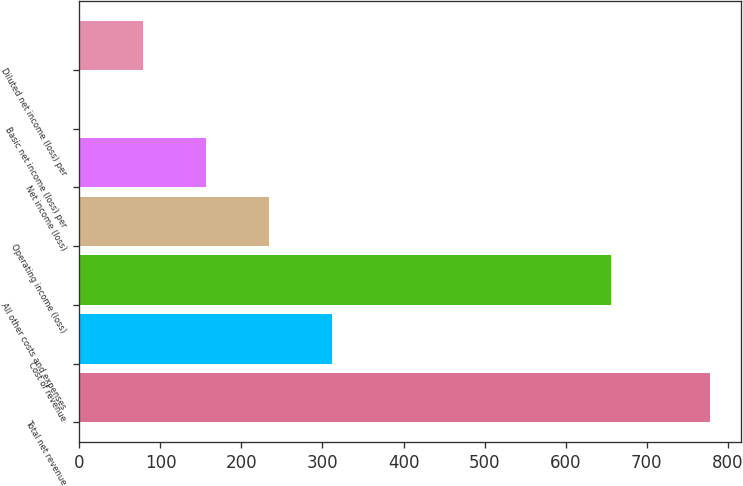Convert chart to OTSL. <chart><loc_0><loc_0><loc_500><loc_500><bar_chart><fcel>Total net revenue<fcel>Cost of revenue<fcel>All other costs and expenses<fcel>Operating income (loss)<fcel>Net income (loss)<fcel>Basic net income (loss) per<fcel>Diluted net income (loss) per<nl><fcel>778<fcel>311.28<fcel>656<fcel>233.49<fcel>155.7<fcel>0.12<fcel>77.91<nl></chart> 